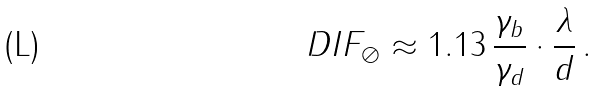Convert formula to latex. <formula><loc_0><loc_0><loc_500><loc_500>D I F _ { \oslash } \approx 1 . 1 3 \, \frac { \gamma _ { b } } { \gamma _ { d } } \cdot \frac { \lambda } { d } \, .</formula> 